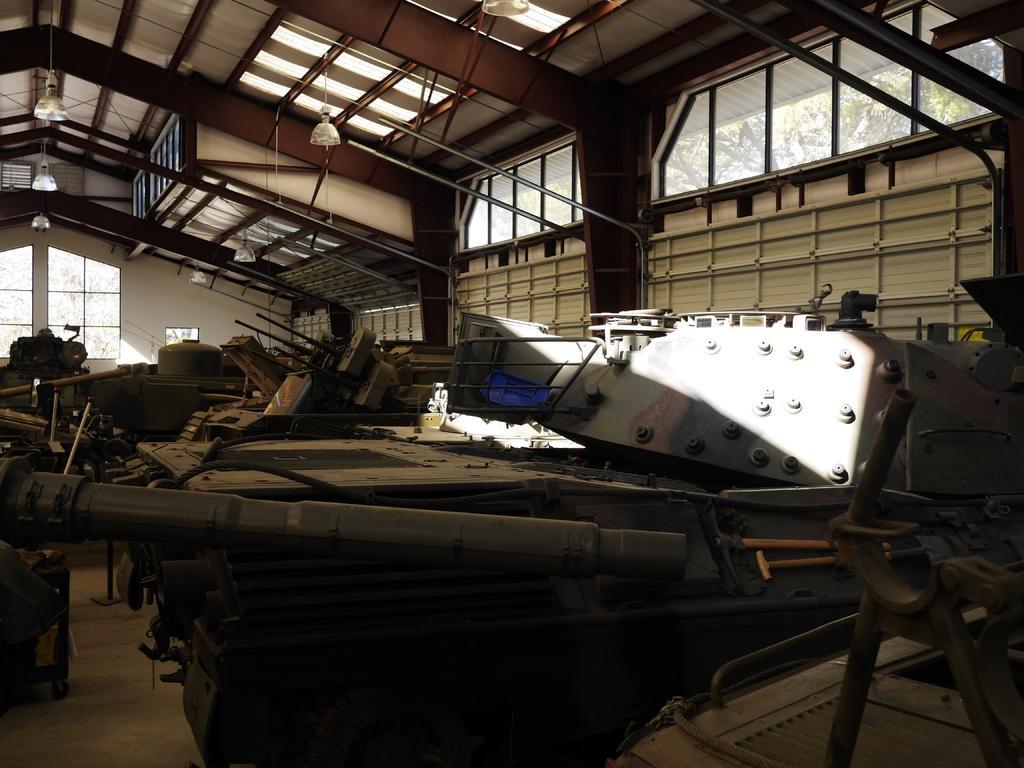In one or two sentences, can you explain what this image depicts? In this image we can see many iron materials. There are rods. There are glass windows. On the ceiling there are lights. Through the glass windows we can see branches of trees. 